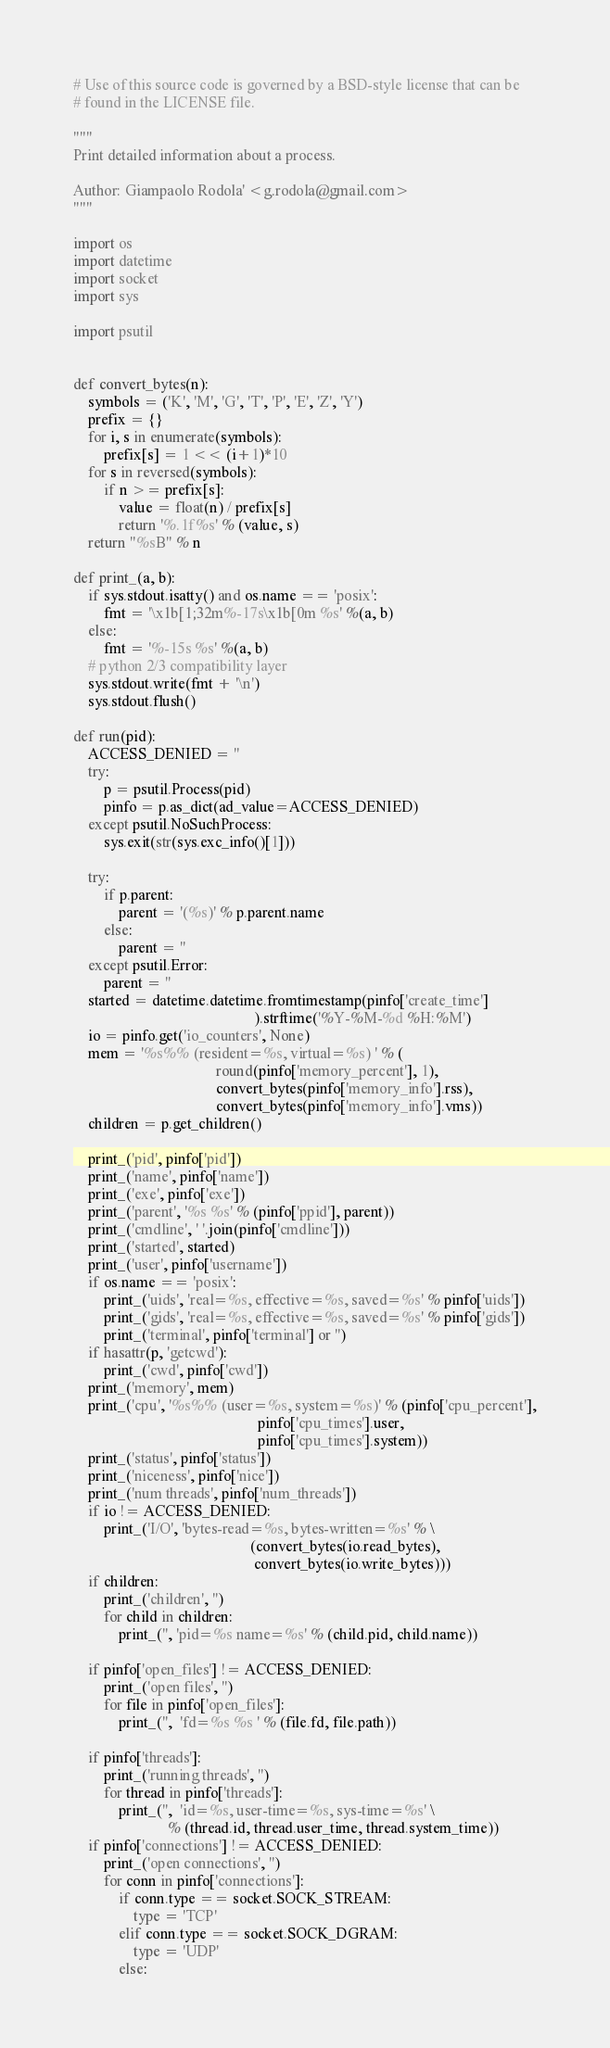Convert code to text. <code><loc_0><loc_0><loc_500><loc_500><_Python_># Use of this source code is governed by a BSD-style license that can be
# found in the LICENSE file.

"""
Print detailed information about a process.

Author: Giampaolo Rodola' <g.rodola@gmail.com>
"""

import os
import datetime
import socket
import sys

import psutil


def convert_bytes(n):
    symbols = ('K', 'M', 'G', 'T', 'P', 'E', 'Z', 'Y')
    prefix = {}
    for i, s in enumerate(symbols):
        prefix[s] = 1 << (i+1)*10
    for s in reversed(symbols):
        if n >= prefix[s]:
            value = float(n) / prefix[s]
            return '%.1f%s' % (value, s)
    return "%sB" % n

def print_(a, b):
    if sys.stdout.isatty() and os.name == 'posix':
        fmt = '\x1b[1;32m%-17s\x1b[0m %s' %(a, b)
    else:
        fmt = '%-15s %s' %(a, b)
    # python 2/3 compatibility layer
    sys.stdout.write(fmt + '\n')
    sys.stdout.flush()

def run(pid):
    ACCESS_DENIED = ''
    try:
        p = psutil.Process(pid)
        pinfo = p.as_dict(ad_value=ACCESS_DENIED)
    except psutil.NoSuchProcess:
        sys.exit(str(sys.exc_info()[1]))

    try:
        if p.parent:
            parent = '(%s)' % p.parent.name
        else:
            parent = ''
    except psutil.Error:
        parent = ''
    started = datetime.datetime.fromtimestamp(pinfo['create_time']
                                                ).strftime('%Y-%M-%d %H:%M')
    io = pinfo.get('io_counters', None)
    mem = '%s%% (resident=%s, virtual=%s) ' % (
                                      round(pinfo['memory_percent'], 1),
                                      convert_bytes(pinfo['memory_info'].rss),
                                      convert_bytes(pinfo['memory_info'].vms))
    children = p.get_children()

    print_('pid', pinfo['pid'])
    print_('name', pinfo['name'])
    print_('exe', pinfo['exe'])
    print_('parent', '%s %s' % (pinfo['ppid'], parent))
    print_('cmdline', ' '.join(pinfo['cmdline']))
    print_('started', started)
    print_('user', pinfo['username'])
    if os.name == 'posix':
        print_('uids', 'real=%s, effective=%s, saved=%s' % pinfo['uids'])
        print_('gids', 'real=%s, effective=%s, saved=%s' % pinfo['gids'])
        print_('terminal', pinfo['terminal'] or '')
    if hasattr(p, 'getcwd'):
        print_('cwd', pinfo['cwd'])
    print_('memory', mem)
    print_('cpu', '%s%% (user=%s, system=%s)' % (pinfo['cpu_percent'],
                                                 pinfo['cpu_times'].user,
                                                 pinfo['cpu_times'].system))
    print_('status', pinfo['status'])
    print_('niceness', pinfo['nice'])
    print_('num threads', pinfo['num_threads'])
    if io != ACCESS_DENIED:
        print_('I/O', 'bytes-read=%s, bytes-written=%s' % \
                                               (convert_bytes(io.read_bytes),
                                                convert_bytes(io.write_bytes)))
    if children:
        print_('children', '')
        for child in children:
            print_('', 'pid=%s name=%s' % (child.pid, child.name))

    if pinfo['open_files'] != ACCESS_DENIED:
        print_('open files', '')
        for file in pinfo['open_files']:
            print_('',  'fd=%s %s ' % (file.fd, file.path))

    if pinfo['threads']:
        print_('running threads', '')
        for thread in pinfo['threads']:
            print_('',  'id=%s, user-time=%s, sys-time=%s' \
                         % (thread.id, thread.user_time, thread.system_time))
    if pinfo['connections'] != ACCESS_DENIED:
        print_('open connections', '')
        for conn in pinfo['connections']:
            if conn.type == socket.SOCK_STREAM:
                type = 'TCP'
            elif conn.type == socket.SOCK_DGRAM:
                type = 'UDP'
            else:</code> 